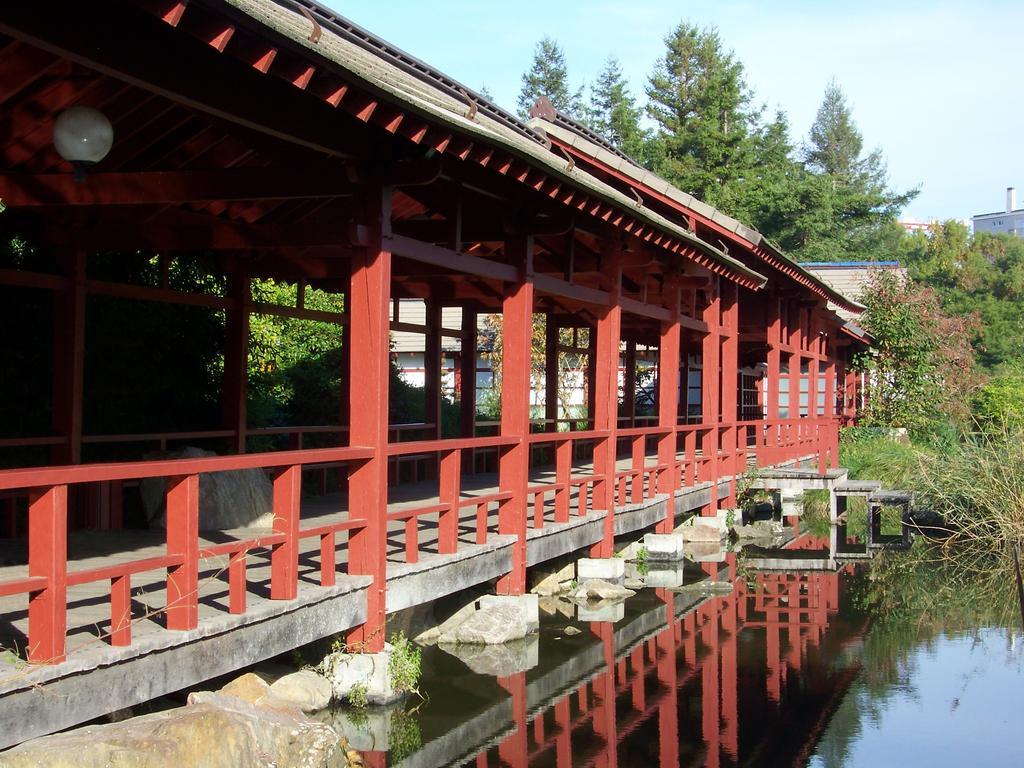In one or two sentences, can you explain what this image depicts? In this image I can see few buildings,shed,fencing,trees,water and stones. The sky is in blue color. 